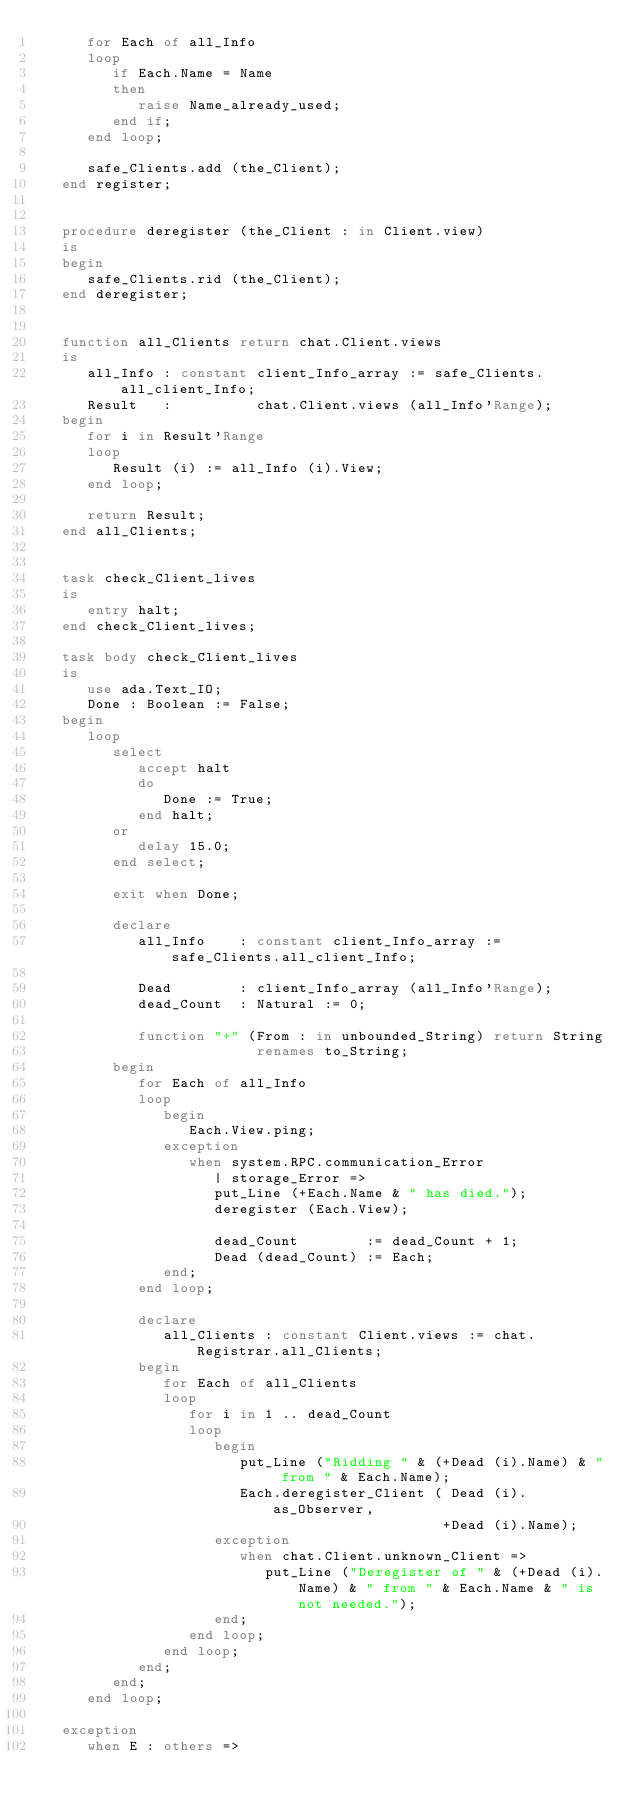Convert code to text. <code><loc_0><loc_0><loc_500><loc_500><_Ada_>      for Each of all_Info
      loop
         if Each.Name = Name
         then
            raise Name_already_used;
         end if;
      end loop;

      safe_Clients.add (the_Client);
   end register;


   procedure deregister (the_Client : in Client.view)
   is
   begin
      safe_Clients.rid (the_Client);
   end deregister;


   function all_Clients return chat.Client.views
   is
      all_Info : constant client_Info_array := safe_Clients.all_client_Info;
      Result   :          chat.Client.views (all_Info'Range);
   begin
      for i in Result'Range
      loop
         Result (i) := all_Info (i).View;
      end loop;

      return Result;
   end all_Clients;


   task check_Client_lives
   is
      entry halt;
   end check_Client_lives;

   task body check_Client_lives
   is
      use ada.Text_IO;
      Done : Boolean := False;
   begin
      loop
         select
            accept halt
            do
               Done := True;
            end halt;
         or
            delay 15.0;
         end select;

         exit when Done;

         declare
            all_Info    : constant client_Info_array := safe_Clients.all_client_Info;

            Dead        : client_Info_array (all_Info'Range);
            dead_Count  : Natural := 0;

            function "+" (From : in unbounded_String) return String
                          renames to_String;
         begin
            for Each of all_Info
            loop
               begin
                  Each.View.ping;
               exception
                  when system.RPC.communication_Error
                     | storage_Error =>
                     put_Line (+Each.Name & " has died.");
                     deregister (Each.View);

                     dead_Count        := dead_Count + 1;
                     Dead (dead_Count) := Each;
               end;
            end loop;

            declare
               all_Clients : constant Client.views := chat.Registrar.all_Clients;
            begin
               for Each of all_Clients
               loop
                  for i in 1 .. dead_Count
                  loop
                     begin
                        put_Line ("Ridding " & (+Dead (i).Name) & " from " & Each.Name);
                        Each.deregister_Client ( Dead (i).as_Observer,
                                                +Dead (i).Name);
                     exception
                        when chat.Client.unknown_Client =>
                           put_Line ("Deregister of " & (+Dead (i).Name) & " from " & Each.Name & " is not needed.");
                     end;
                  end loop;
               end loop;
            end;
         end;
      end loop;

   exception
      when E : others =></code> 